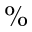Convert formula to latex. <formula><loc_0><loc_0><loc_500><loc_500>\%</formula> 